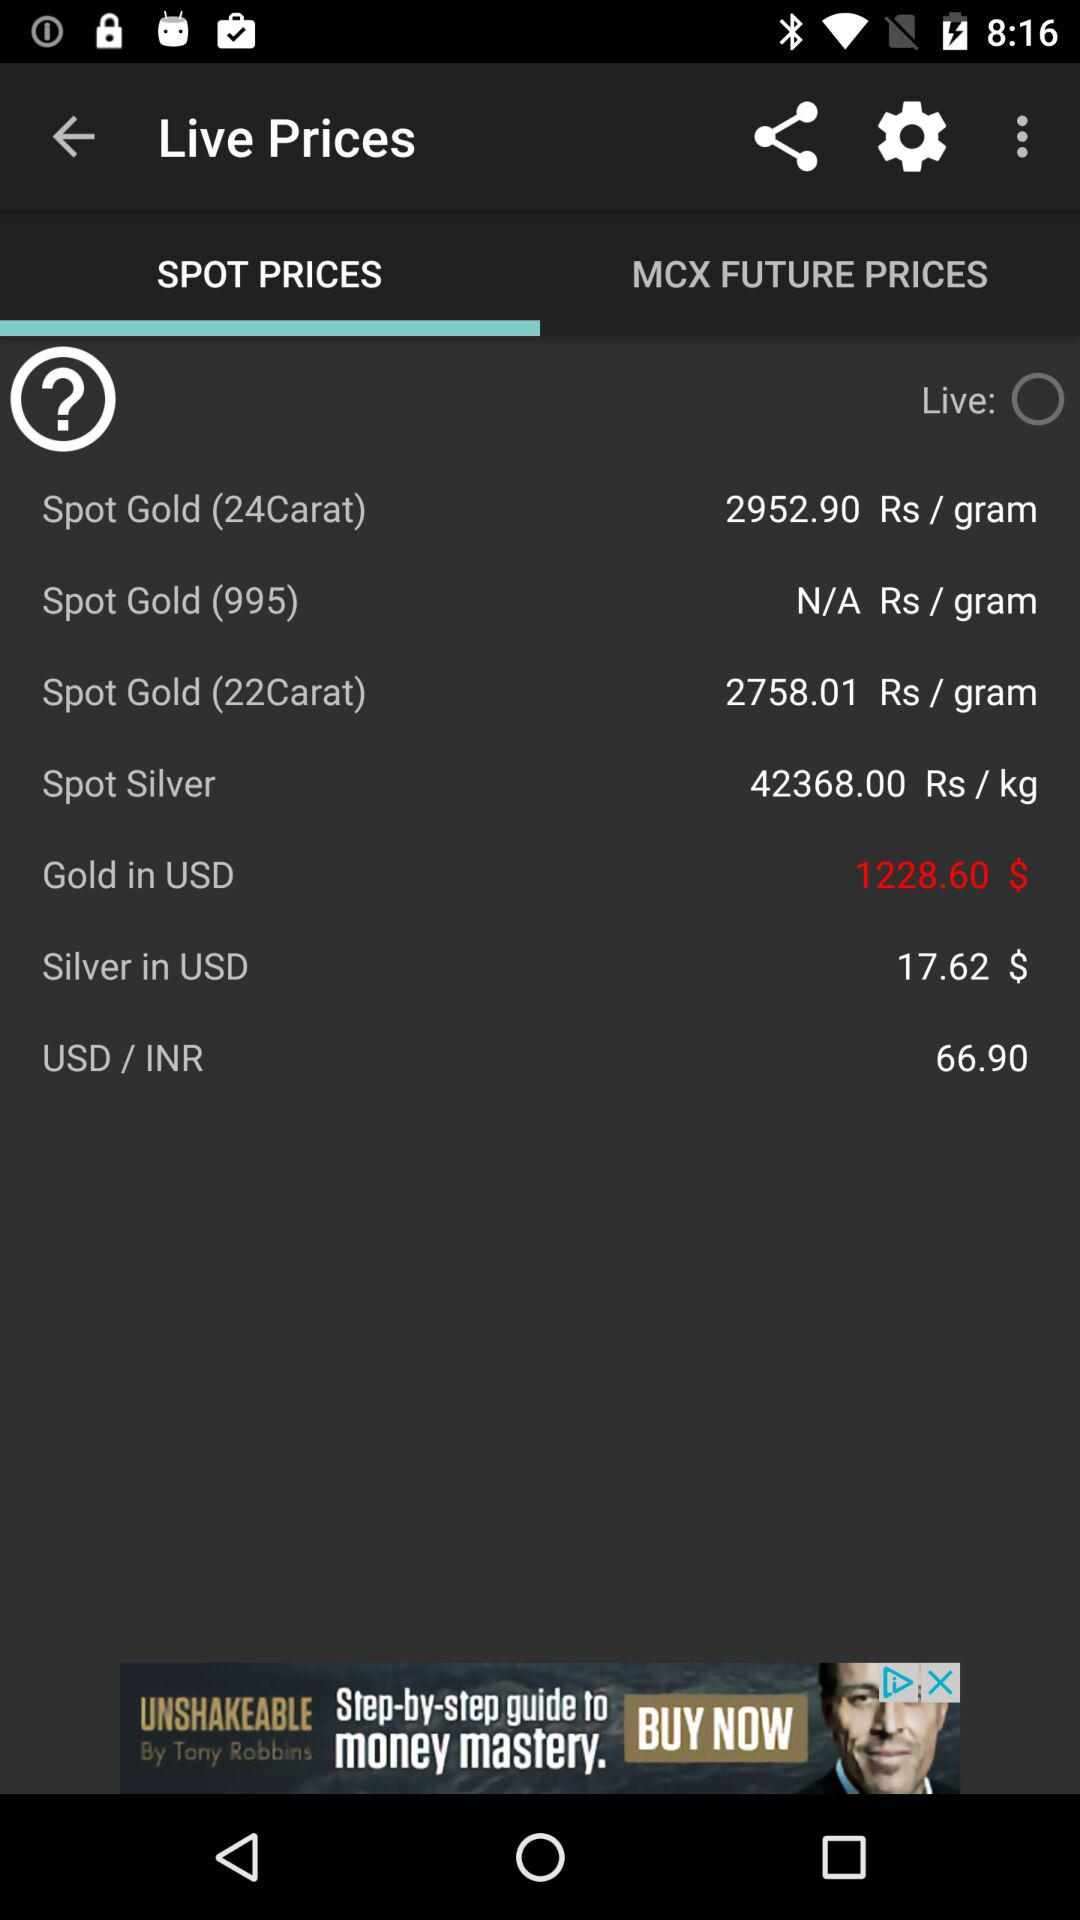Which option has been selected? The selected option is "SPOT PRICES". 